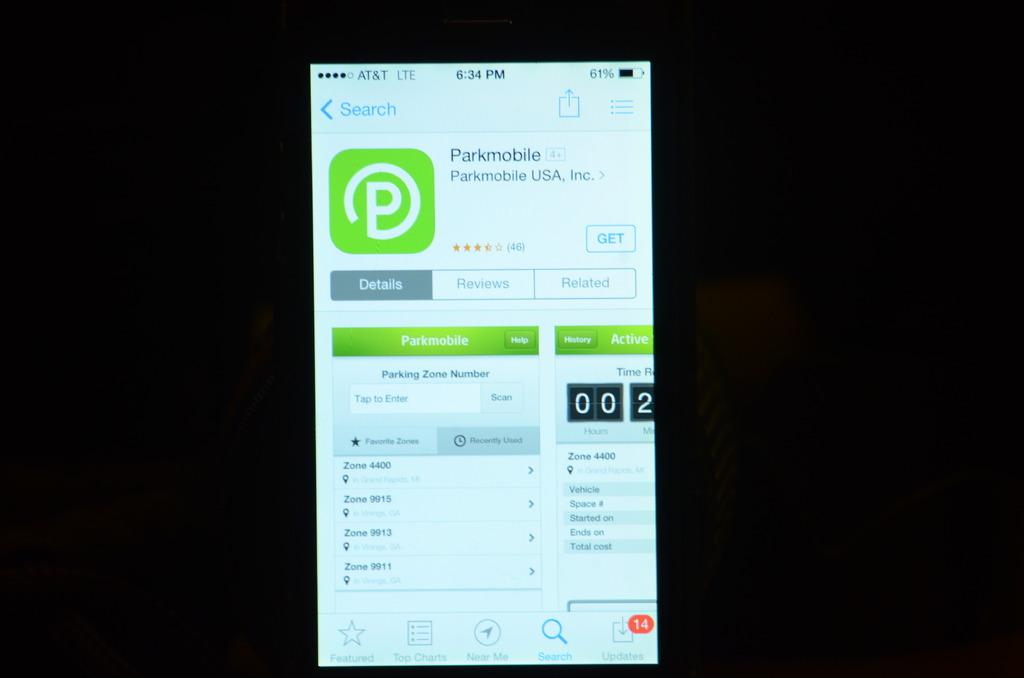Provide a one-sentence caption for the provided image. a screen of a cellphone with Parkmobile carrier. 